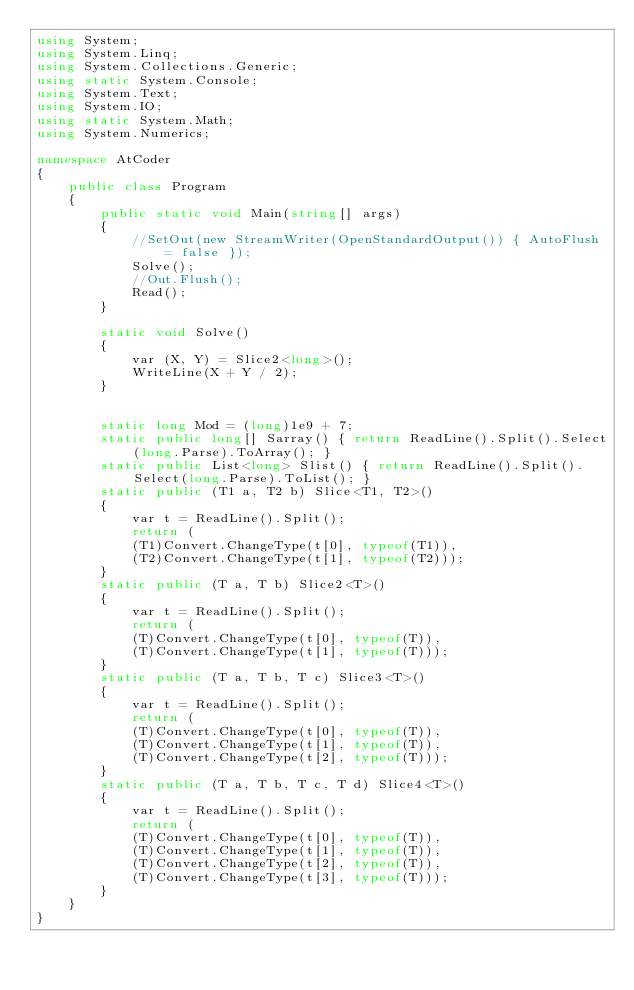Convert code to text. <code><loc_0><loc_0><loc_500><loc_500><_C#_>using System;
using System.Linq;
using System.Collections.Generic;
using static System.Console;
using System.Text;
using System.IO;
using static System.Math;
using System.Numerics;

namespace AtCoder
{
    public class Program
    {
        public static void Main(string[] args)
        {
            //SetOut(new StreamWriter(OpenStandardOutput()) { AutoFlush = false });
            Solve();
            //Out.Flush();
            Read();
        }

        static void Solve()
        {
            var (X, Y) = Slice2<long>();
            WriteLine(X + Y / 2);
        }


        static long Mod = (long)1e9 + 7;
        static public long[] Sarray() { return ReadLine().Split().Select(long.Parse).ToArray(); }
        static public List<long> Slist() { return ReadLine().Split().Select(long.Parse).ToList(); }
        static public (T1 a, T2 b) Slice<T1, T2>()
        {
            var t = ReadLine().Split();
            return (
            (T1)Convert.ChangeType(t[0], typeof(T1)),
            (T2)Convert.ChangeType(t[1], typeof(T2)));
        }
        static public (T a, T b) Slice2<T>()
        {
            var t = ReadLine().Split();
            return (
            (T)Convert.ChangeType(t[0], typeof(T)),
            (T)Convert.ChangeType(t[1], typeof(T)));
        }
        static public (T a, T b, T c) Slice3<T>()
        {
            var t = ReadLine().Split();
            return (
            (T)Convert.ChangeType(t[0], typeof(T)),
            (T)Convert.ChangeType(t[1], typeof(T)),
            (T)Convert.ChangeType(t[2], typeof(T)));
        }
        static public (T a, T b, T c, T d) Slice4<T>()
        {
            var t = ReadLine().Split();
            return (
            (T)Convert.ChangeType(t[0], typeof(T)),
            (T)Convert.ChangeType(t[1], typeof(T)),
            (T)Convert.ChangeType(t[2], typeof(T)),
            (T)Convert.ChangeType(t[3], typeof(T)));
        }
    }
}</code> 